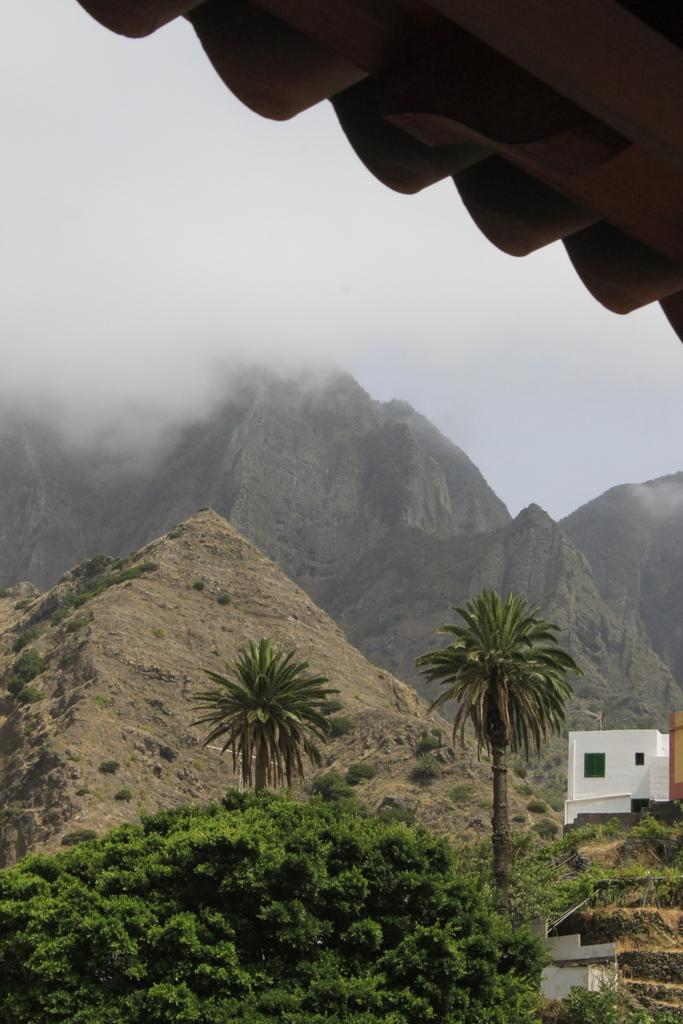What type of structures can be seen in the image? There are houses in the image. What type of natural elements are present in the image? There are trees and hills visible in the image. What atmospheric condition can be observed in the image? There is fog visible in the image. What type of yam is being used as an example in the image? There is no yam present in the image, and therefore no such example can be observed. What type of discovery is being made in the image? There is no discovery being made in the image; it features houses, trees, hills, and fog. 